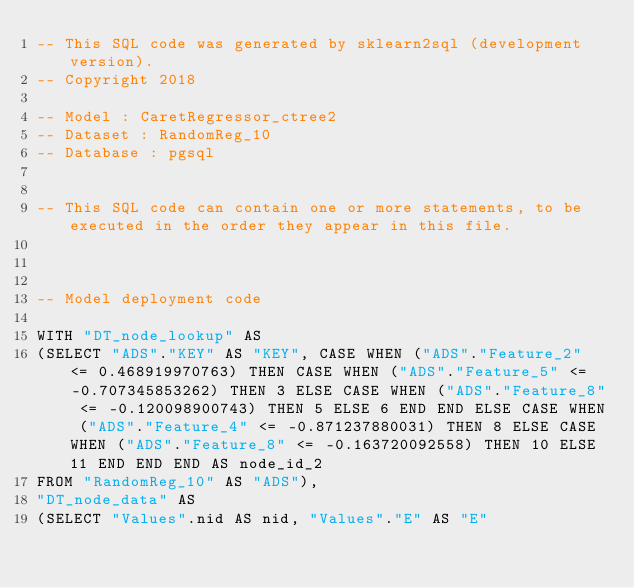<code> <loc_0><loc_0><loc_500><loc_500><_SQL_>-- This SQL code was generated by sklearn2sql (development version).
-- Copyright 2018

-- Model : CaretRegressor_ctree2
-- Dataset : RandomReg_10
-- Database : pgsql


-- This SQL code can contain one or more statements, to be executed in the order they appear in this file.



-- Model deployment code

WITH "DT_node_lookup" AS 
(SELECT "ADS"."KEY" AS "KEY", CASE WHEN ("ADS"."Feature_2" <= 0.468919970763) THEN CASE WHEN ("ADS"."Feature_5" <= -0.707345853262) THEN 3 ELSE CASE WHEN ("ADS"."Feature_8" <= -0.120098900743) THEN 5 ELSE 6 END END ELSE CASE WHEN ("ADS"."Feature_4" <= -0.871237880031) THEN 8 ELSE CASE WHEN ("ADS"."Feature_8" <= -0.163720092558) THEN 10 ELSE 11 END END END AS node_id_2 
FROM "RandomReg_10" AS "ADS"), 
"DT_node_data" AS 
(SELECT "Values".nid AS nid, "Values"."E" AS "E" </code> 